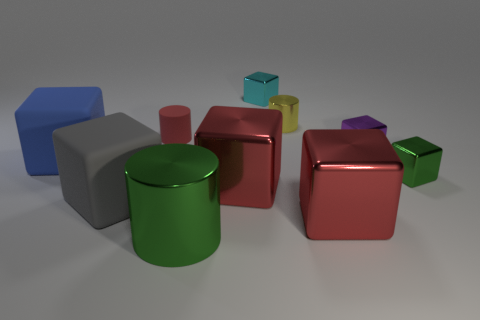Are there any other things that have the same material as the small green cube?
Provide a short and direct response. Yes. How many large blocks are in front of the big blue cube?
Offer a terse response. 3. There is a purple thing that is the same shape as the small green thing; what is its size?
Offer a terse response. Small. There is a metal cube that is to the left of the tiny purple block and on the right side of the yellow metal thing; what is its size?
Offer a very short reply. Large. Is the color of the large cylinder the same as the big shiny cube that is behind the gray rubber cube?
Offer a terse response. No. How many gray objects are either metallic objects or large metal blocks?
Offer a very short reply. 0. What is the shape of the purple metal object?
Provide a succinct answer. Cube. How many other things are the same shape as the small yellow metallic object?
Provide a short and direct response. 2. The metallic cylinder right of the cyan shiny block is what color?
Keep it short and to the point. Yellow. Is the tiny red thing made of the same material as the big green cylinder?
Keep it short and to the point. No. 